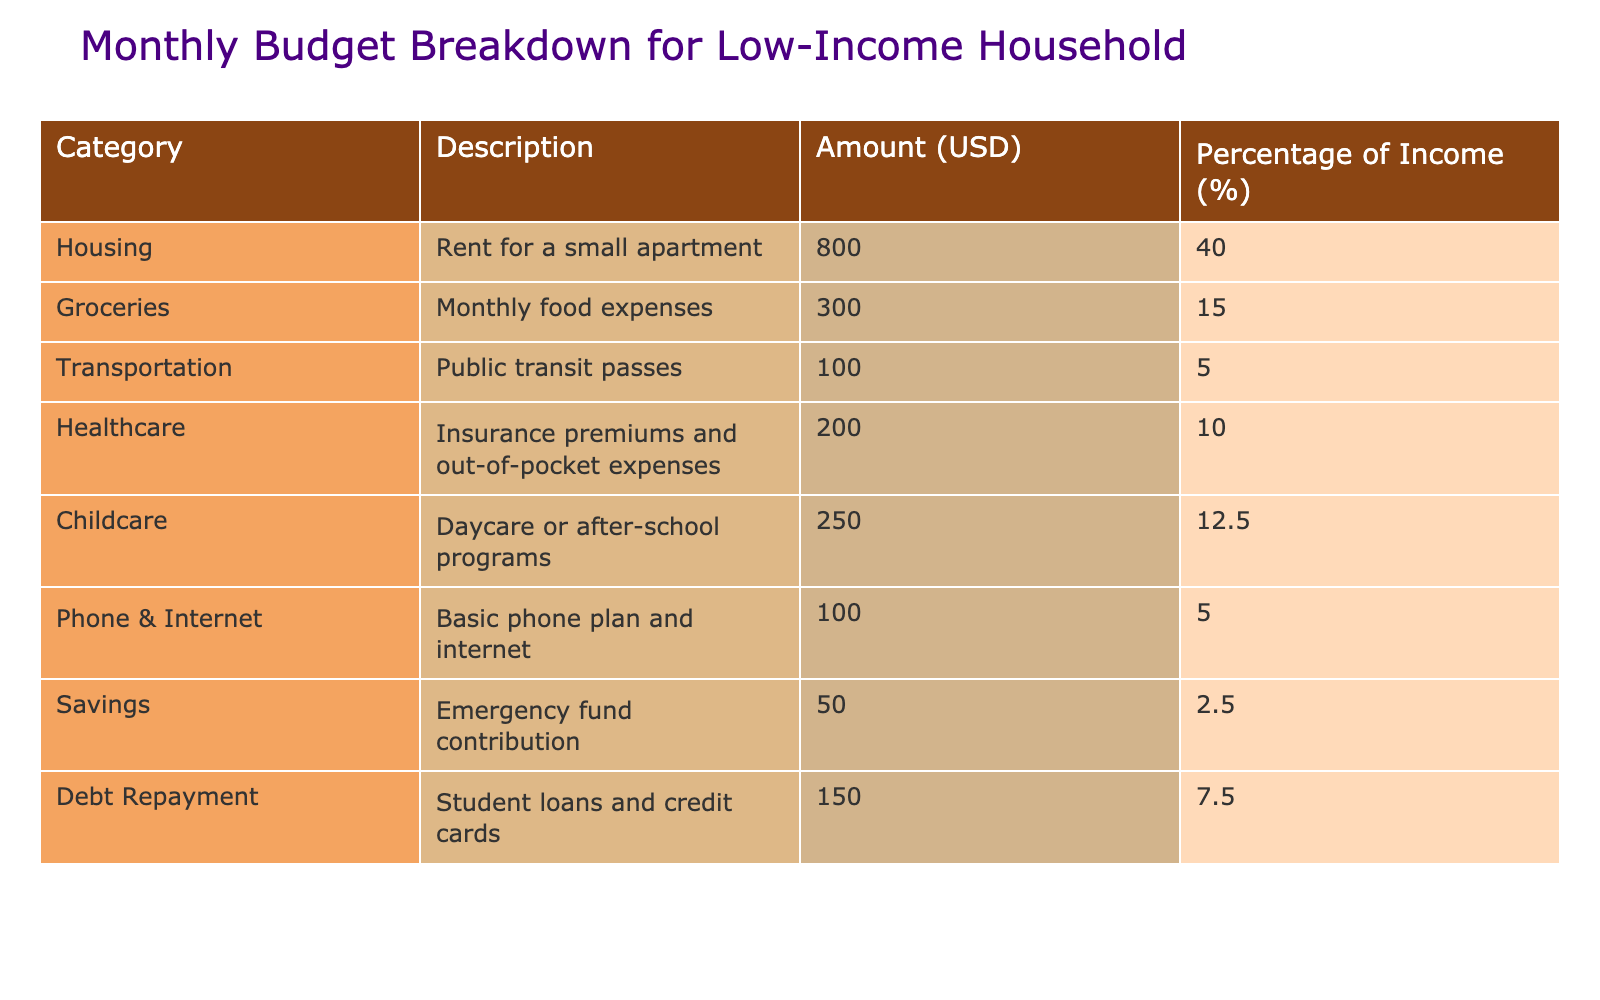What is the total amount spent on housing? The table shows that the amount spent on housing (rent for a small apartment) is $800.
Answer: 800 What percentage of income is allocated to groceries? The table indicates that the percentage of income allocated to groceries is 15%.
Answer: 15% What are the total monthly expenses for transportation and healthcare combined? Transportation costs $100 and healthcare costs $200, so the combined total is $100 + $200 = $300.
Answer: 300 Is the amount spent on childcare higher than that on healthcare? The amount for childcare is $250 and healthcare is $200, since $250 is greater than $200, the answer is yes.
Answer: Yes What is the percentage of income spent on savings? The table states that the amount spent on savings is 2.5% of income.
Answer: 2.5% If the household reduces its grocery expenses by $50, what would be the new percentage of income for groceries? Current grocery spending is $300. Reducing it by $50 gives $250. Since the total income is $2000 (based on percentages), the new percentage would be (250/2000) * 100 = 12.5%.
Answer: 12.5% What is the total percentage of income allocated to debt repayment and savings combined? The percentage allocated to debt repayment is 7.5% and savings is 2.5%, so the combined total is 7.5% + 2.5% = 10%.
Answer: 10% If the household has a total monthly income of $2000, how much money remains after covering all expenses? The total expenses are calculated by adding all categories, which sums up to $2000. Therefore, income ($2000) minus expenses ($2000) equals $0.
Answer: 0 Which expense category represents the highest percentage of income? By reviewing the percentages, housing represents the highest at 40%.
Answer: 40% What would the total monthly expenses be if the household increases childcare by $100? Adding $100 to the current $250 for childcare gives $350 for childcare. The total current expenses are $2000, so the new total would be $2000 + $100 = $2100.
Answer: 2100 